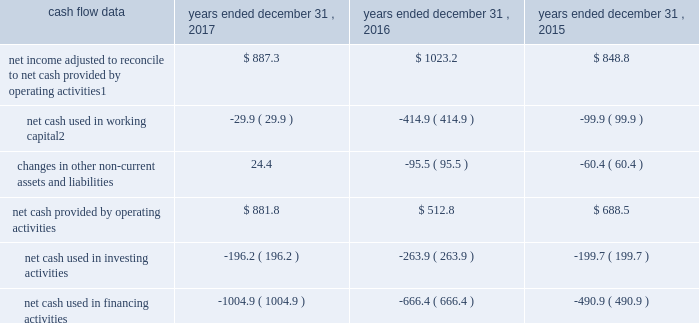Management 2019s discussion and analysis of financial condition and results of operations 2013 ( continued ) ( amounts in millions , except per share amounts ) operating income increased during 2017 when compared to 2016 , comprised of a decrease in revenue of $ 42.1 , as discussed above , a decrease in salaries and related expenses of $ 28.0 and a decrease in office and general expenses of $ 16.9 .
The decrease in salaries and related expenses was primarily due to lower discretionary bonuses and incentive expense as well as a decrease in base salaries , benefits and tax .
The decrease in office and general expenses was primarily due to decreases in adjustments to contingent acquisition obligations , as compared to the prior year .
Operating income increased during 2016 when compared to 2015 due to an increase in revenue of $ 58.8 , as discussed above , and a decrease in office and general expenses of $ 3.7 , partially offset by an increase in salaries and related expenses of $ 38.8 .
The increase in salaries and related expenses was attributable to an increase in base salaries , benefits and tax primarily due to increases in our workforce to support business growth over the last twelve months .
The decrease in office and general expenses was primarily due to lower production expenses related to pass-through costs , which are also reflected in revenue , for certain projects in which we acted as principal that decreased in size or did not recur during the current year .
Corporate and other certain corporate and other charges are reported as a separate line item within total segment operating income and include corporate office expenses , as well as shared service center and certain other centrally managed expenses that are not fully allocated to operating divisions .
Salaries and related expenses include salaries , long-term incentives , annual bonuses and other miscellaneous benefits for corporate office employees .
Office and general expenses primarily include professional fees related to internal control compliance , financial statement audits and legal , information technology and other consulting services that are engaged and managed through the corporate office .
Office and general expenses also include rental expense and depreciation of leasehold improvements for properties occupied by corporate office employees .
A portion of centrally managed expenses are allocated to operating divisions based on a formula that uses the planned revenues of each of the operating units .
Amounts allocated also include specific charges for information technology-related projects , which are allocated based on utilization .
Corporate and other expenses decreased during 2017 by $ 20.6 to $ 126.6 compared to 2016 , primarily due to lower annual incentive expense .
Corporate and other expenses increased during 2016 by $ 5.4 to $ 147.2 compared to 2015 .
Liquidity and capital resources cash flow overview the tables summarize key financial data relating to our liquidity , capital resources and uses of capital. .
1 reflects net income adjusted primarily for depreciation and amortization of fixed assets and intangible assets , amortization of restricted stock and other non-cash compensation , net losses on sales of businesses and deferred income taxes .
2 reflects changes in accounts receivable , expenditures billable to clients , other current assets , accounts payable and accrued liabilities .
Operating activities due to the seasonality of our business , we typically use cash from working capital in the first nine months of a year , with the largest impact in the first quarter , and generate cash from working capital in the fourth quarter , driven by the seasonally strong media spending by our clients .
Quarterly and annual working capital results are impacted by the fluctuating annual media spending budgets of our clients as well as their changing media spending patterns throughout each year across various countries. .
What was the total amount of corporate and other expenses from 2015-2017? 
Computations: ((147.2 + (147.2 - 5.4)) + 126.6)
Answer: 415.6. 